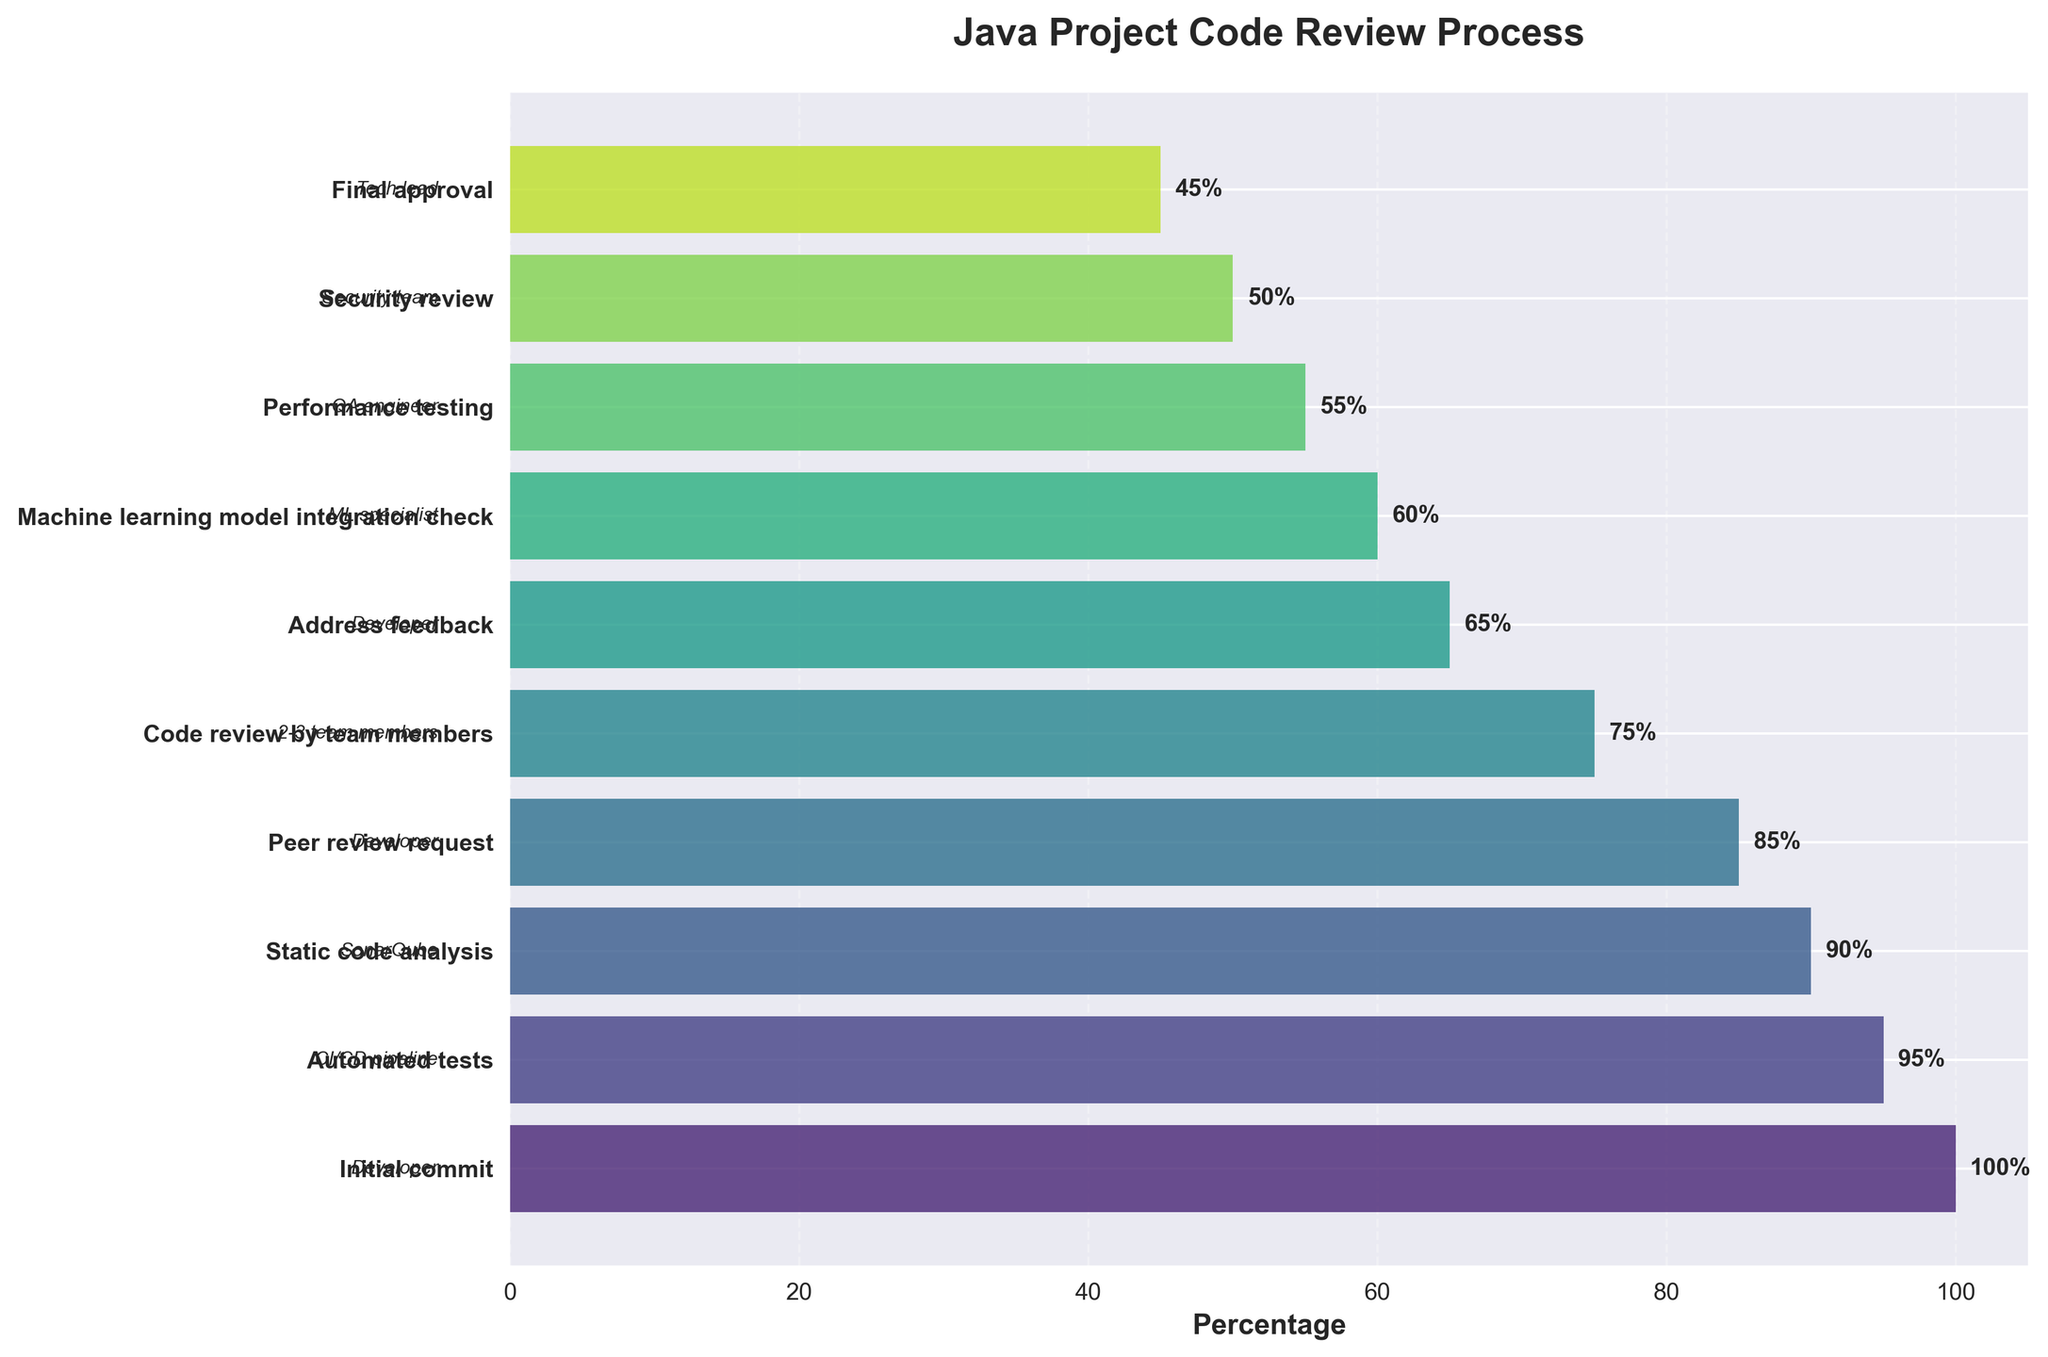What is the title of the funnel chart? The title of the chart is located at the top of the figure, representing the main subject of the chart. It is boldly printed.
Answer: Java Project Code Review Process How many steps are depicted in the funnel chart? The number of steps can be counted based on the y-axis labels, each representing a distinct step in the code review process.
Answer: 10 Which step has the highest percentage? Look for the step that has the bar extending the furthest towards the right on the x-axis, indicating the highest percentage. This corresponds to the first entry in the chart.
Answer: Initial commit What percentage of participants complete the 'Peer review request' step? Identify the 'Peer review request' label on the y-axis and read the corresponding value on the x-axis or the percentage label aligned with it.
Answer: 85% Which step involves the smallest percentage of participants? Look for the step where the bar is the shortest on the x-axis, indicating the smallest percentage of participants. This corresponds to the last entry in the chart.
Answer: Final approval What is the difference in percentage between 'Automated tests' and 'Security review'? Identify the percentage values for 'Automated tests' and 'Security review' steps and compute the difference: 95% - 50%.
Answer: 45% Which step occurs immediately after 'Address feedback'? Find 'Address feedback' on the y-axis and identify the label right above or below it according to the sequence of steps.
Answer: Machine learning model integration check Compare the participants' number in 'Code review by team members' with those in 'Performance testing'. Which group has more participants and by what percentage? Compare the percentage of participants in both steps: 'Code review by team members' (75%) and 'Performance testing' (55%), and calculate: 75% - 55%.
Answer: Code review by team members by 20% What is the average percentage for all steps in the funnel chart? Sum up the percentages of all steps and then divide by the number of steps: (100 + 95 + 90 + 85 + 75 + 65 + 60 + 55 + 50 + 45) / 10
Answer: 72% How does the percentage change from 'Static code analysis' to 'Code review by team members'? Identify the percentages for 'Static code analysis' (90%) and 'Code review by team members' (75%), and determine the change by subtracting: 90% - 75%.
Answer: 15% 